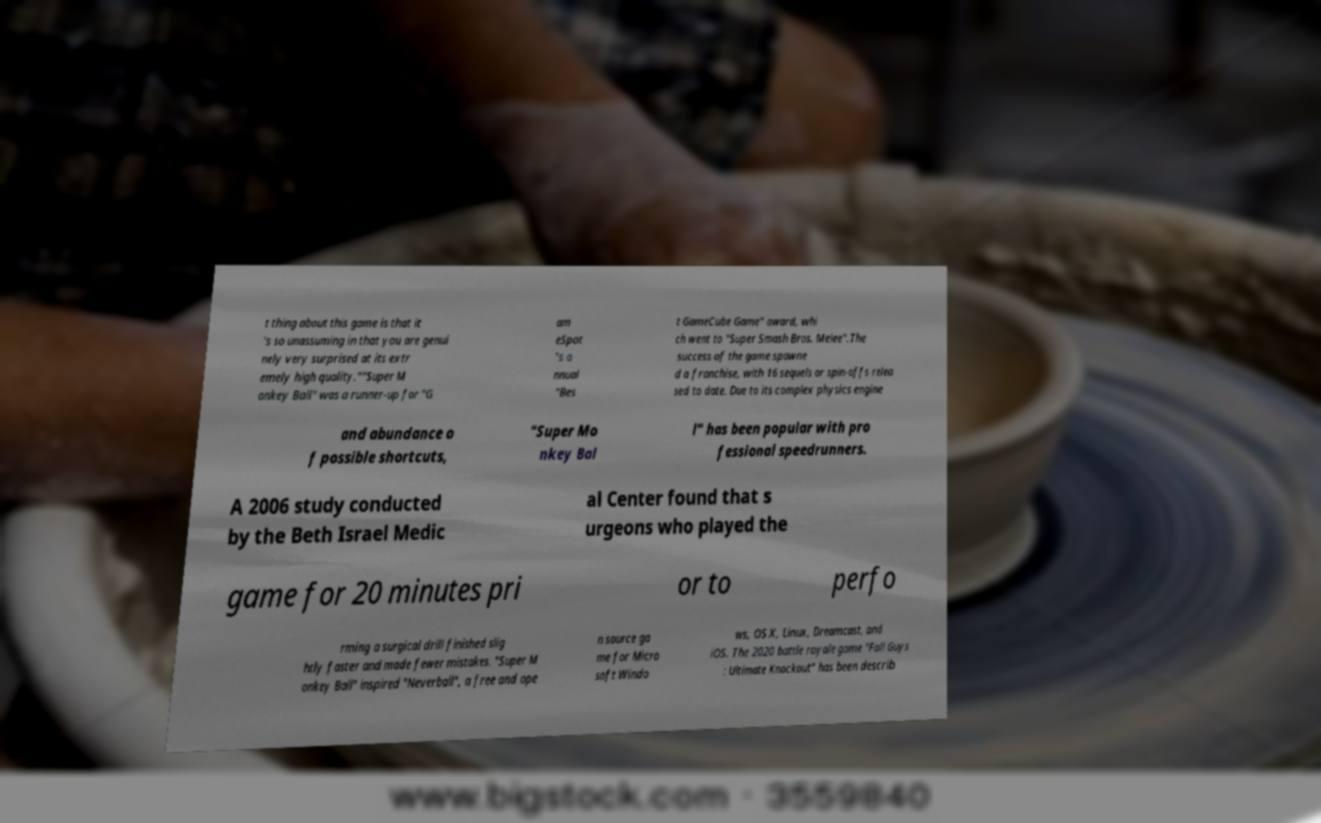Please identify and transcribe the text found in this image. t thing about this game is that it 's so unassuming in that you are genui nely very surprised at its extr emely high quality.""Super M onkey Ball" was a runner-up for "G am eSpot "s a nnual "Bes t GameCube Game" award, whi ch went to "Super Smash Bros. Melee".The success of the game spawne d a franchise, with 16 sequels or spin-offs relea sed to date. Due to its complex physics engine and abundance o f possible shortcuts, "Super Mo nkey Bal l" has been popular with pro fessional speedrunners. A 2006 study conducted by the Beth Israel Medic al Center found that s urgeons who played the game for 20 minutes pri or to perfo rming a surgical drill finished slig htly faster and made fewer mistakes. "Super M onkey Ball" inspired "Neverball", a free and ope n source ga me for Micro soft Windo ws, OS X, Linux, Dreamcast, and iOS. The 2020 battle royale game "Fall Guys : Ultimate Knockout" has been describ 